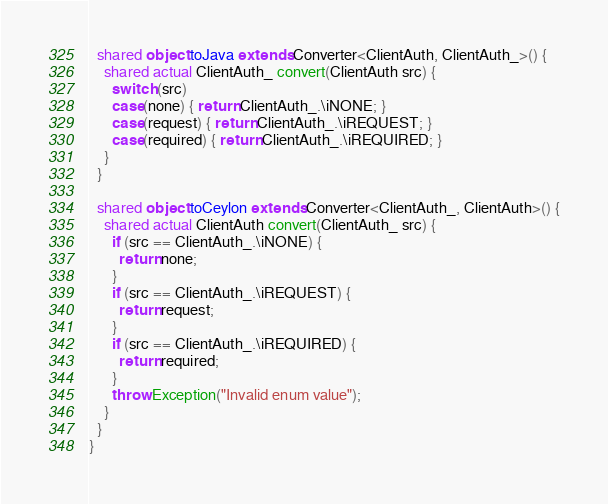Convert code to text. <code><loc_0><loc_0><loc_500><loc_500><_Ceylon_>  shared object toJava extends Converter<ClientAuth, ClientAuth_>() {
    shared actual ClientAuth_ convert(ClientAuth src) {
      switch (src)
      case(none) { return ClientAuth_.\iNONE; }
      case(request) { return ClientAuth_.\iREQUEST; }
      case(required) { return ClientAuth_.\iREQUIRED; }
    }
  }

  shared object toCeylon extends Converter<ClientAuth_, ClientAuth>() {
    shared actual ClientAuth convert(ClientAuth_ src) {
      if (src == ClientAuth_.\iNONE) {
        return none;
      }
      if (src == ClientAuth_.\iREQUEST) {
        return request;
      }
      if (src == ClientAuth_.\iREQUIRED) {
        return required;
      }
      throw Exception("Invalid enum value");
    }
  }
}
</code> 